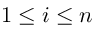Convert formula to latex. <formula><loc_0><loc_0><loc_500><loc_500>1 \leq i \leq n</formula> 